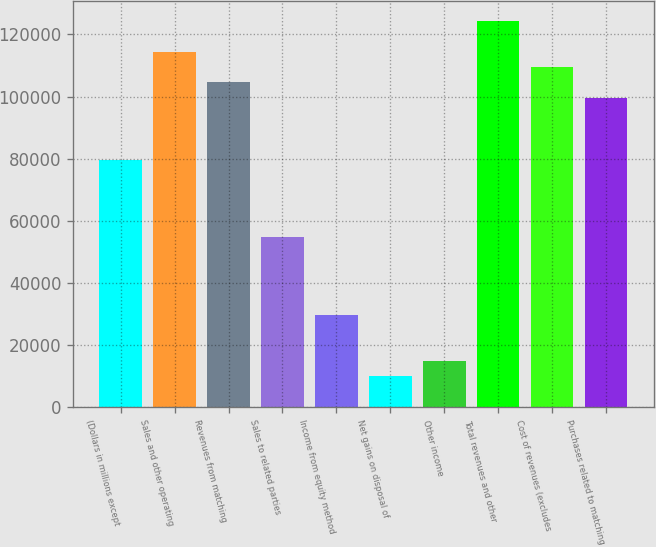<chart> <loc_0><loc_0><loc_500><loc_500><bar_chart><fcel>(Dollars in millions except<fcel>Sales and other operating<fcel>Revenues from matching<fcel>Sales to related parties<fcel>Income from equity method<fcel>Net gains on disposal of<fcel>Other income<fcel>Total revenues and other<fcel>Cost of revenues (excludes<fcel>Purchases related to matching<nl><fcel>79627.8<fcel>114462<fcel>104509<fcel>54746.3<fcel>29864.8<fcel>9959.6<fcel>14935.9<fcel>124414<fcel>109486<fcel>99533<nl></chart> 